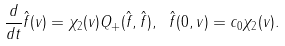<formula> <loc_0><loc_0><loc_500><loc_500>\frac { d } { d t } \hat { f } ( v ) = \chi _ { 2 } ( v ) Q _ { + } ( \hat { f } , \hat { f } ) , \ \hat { f } ( 0 , v ) = c _ { 0 } \chi _ { 2 } ( v ) .</formula> 